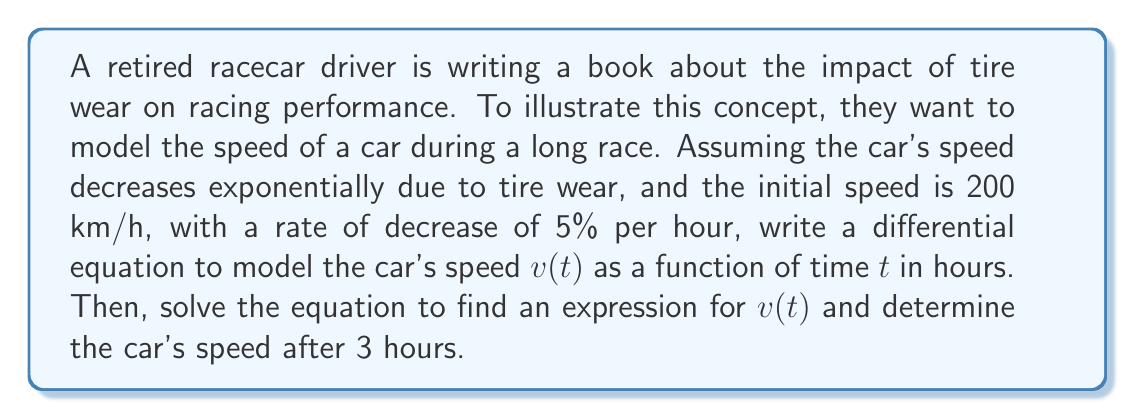Solve this math problem. Let's approach this problem step by step:

1) First, we need to set up the differential equation. The rate of change of speed with respect to time is proportional to the current speed:

   $$\frac{dv}{dt} = -kv$$

   where $k$ is the decay constant.

2) We're told the rate of decrease is 5% per hour. This means $k = 0.05$.

3) So our differential equation is:

   $$\frac{dv}{dt} = -0.05v$$

4) To solve this, we can separate variables:

   $$\frac{dv}{v} = -0.05dt$$

5) Integrating both sides:

   $$\int \frac{dv}{v} = \int -0.05dt$$
   
   $$\ln|v| = -0.05t + C$$

6) Exponentiating both sides:

   $$v = e^{-0.05t + C} = Ae^{-0.05t}$$

   where $A = e^C$ is a constant.

7) To find $A$, we use the initial condition. At $t=0$, $v=200$:

   $$200 = Ae^{-0.05(0)} = A$$

8) Therefore, our solution is:

   $$v(t) = 200e^{-0.05t}$$

9) To find the speed after 3 hours, we substitute $t=3$:

   $$v(3) = 200e^{-0.05(3)} = 200e^{-0.15} \approx 172.45$$
Answer: The differential equation modeling the car's speed is $\frac{dv}{dt} = -0.05v$. The solution is $v(t) = 200e^{-0.05t}$ km/h, where $t$ is in hours. After 3 hours, the car's speed is approximately 172.45 km/h. 